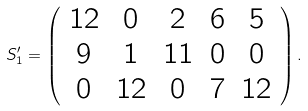<formula> <loc_0><loc_0><loc_500><loc_500>S _ { 1 } ^ { \prime } = \left ( \begin{array} { c c c c c } 1 2 & 0 & 2 & 6 & 5 \\ 9 & 1 & 1 1 & 0 & 0 \\ 0 & 1 2 & 0 & 7 & 1 2 \end{array} \right ) .</formula> 